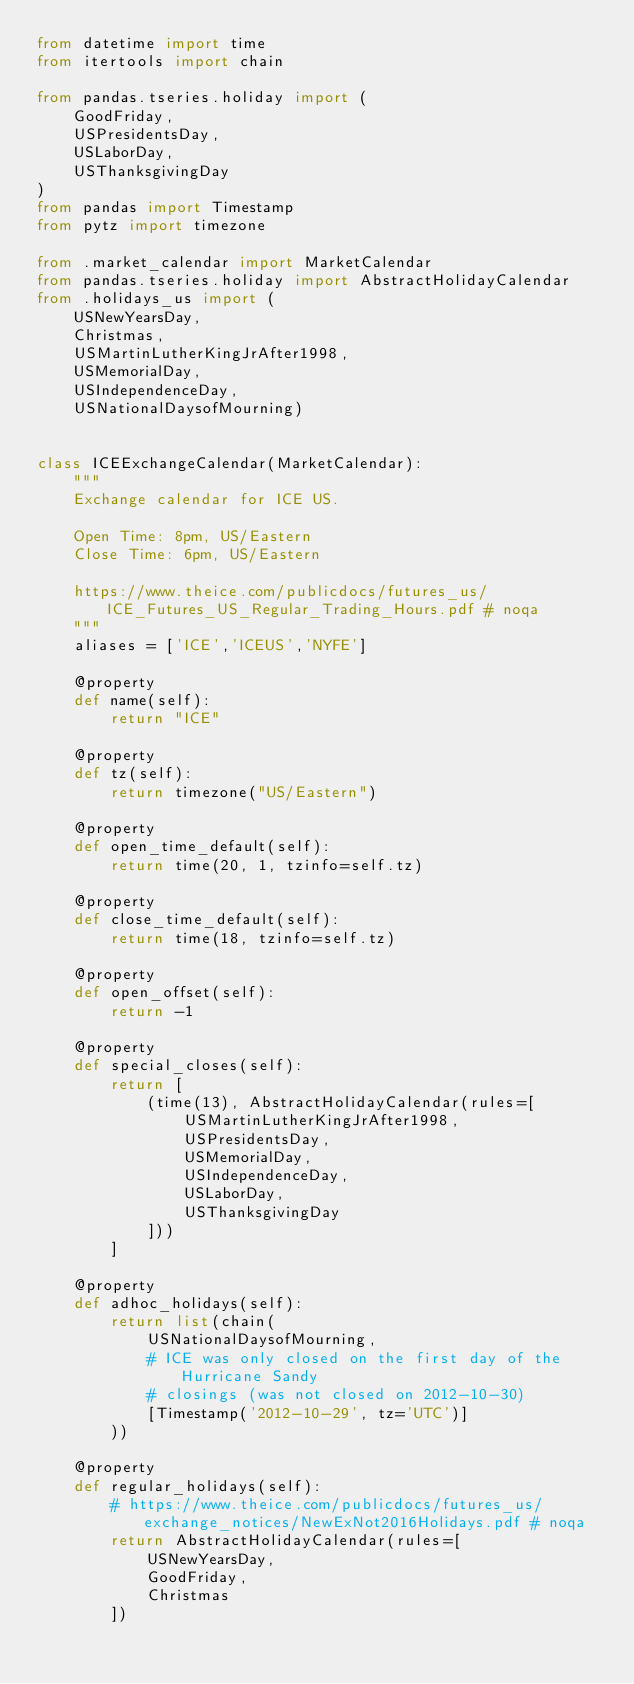Convert code to text. <code><loc_0><loc_0><loc_500><loc_500><_Python_>from datetime import time
from itertools import chain

from pandas.tseries.holiday import (
    GoodFriday,
    USPresidentsDay,
    USLaborDay,
    USThanksgivingDay
)
from pandas import Timestamp
from pytz import timezone

from .market_calendar import MarketCalendar
from pandas.tseries.holiday import AbstractHolidayCalendar
from .holidays_us import (
    USNewYearsDay,
    Christmas,
    USMartinLutherKingJrAfter1998,
    USMemorialDay,
    USIndependenceDay,
    USNationalDaysofMourning)


class ICEExchangeCalendar(MarketCalendar):
    """
    Exchange calendar for ICE US.

    Open Time: 8pm, US/Eastern
    Close Time: 6pm, US/Eastern

    https://www.theice.com/publicdocs/futures_us/ICE_Futures_US_Regular_Trading_Hours.pdf # noqa
    """
    aliases = ['ICE','ICEUS','NYFE']

    @property
    def name(self):
        return "ICE"

    @property
    def tz(self):
        return timezone("US/Eastern")

    @property
    def open_time_default(self):
        return time(20, 1, tzinfo=self.tz)

    @property
    def close_time_default(self):
        return time(18, tzinfo=self.tz)

    @property
    def open_offset(self):
        return -1

    @property
    def special_closes(self):
        return [
            (time(13), AbstractHolidayCalendar(rules=[
                USMartinLutherKingJrAfter1998,
                USPresidentsDay,
                USMemorialDay,
                USIndependenceDay,
                USLaborDay,
                USThanksgivingDay
            ]))
        ]

    @property
    def adhoc_holidays(self):
        return list(chain(
            USNationalDaysofMourning,
            # ICE was only closed on the first day of the Hurricane Sandy
            # closings (was not closed on 2012-10-30)
            [Timestamp('2012-10-29', tz='UTC')]
        ))

    @property
    def regular_holidays(self):
        # https://www.theice.com/publicdocs/futures_us/exchange_notices/NewExNot2016Holidays.pdf # noqa
        return AbstractHolidayCalendar(rules=[
            USNewYearsDay,
            GoodFriday,
            Christmas
        ])
</code> 